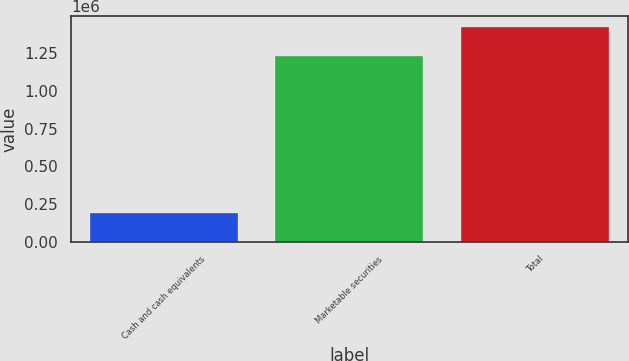<chart> <loc_0><loc_0><loc_500><loc_500><bar_chart><fcel>Cash and cash equivalents<fcel>Marketable securities<fcel>Total<nl><fcel>191608<fcel>1.23308e+06<fcel>1.42468e+06<nl></chart> 